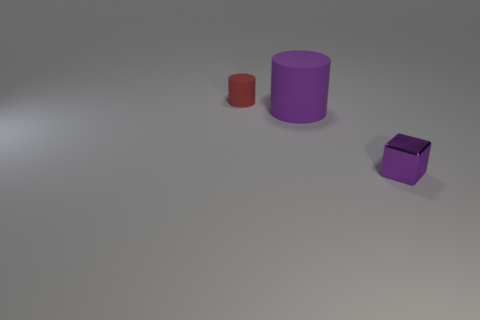Add 1 big purple cylinders. How many objects exist? 4 Subtract all cylinders. How many objects are left? 1 Add 3 small matte cylinders. How many small matte cylinders are left? 4 Add 2 small cylinders. How many small cylinders exist? 3 Subtract 0 cyan cylinders. How many objects are left? 3 Subtract all big balls. Subtract all matte cylinders. How many objects are left? 1 